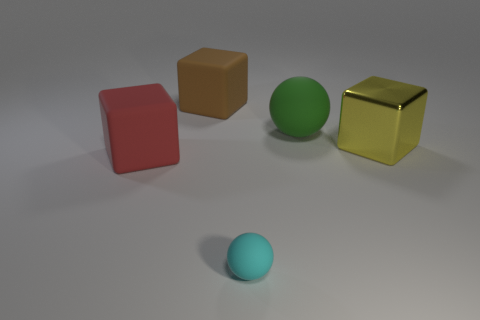Is there any other thing that has the same size as the cyan rubber sphere?
Your response must be concise. No. The cube that is to the left of the rubber block that is on the right side of the matte object on the left side of the brown thing is made of what material?
Your response must be concise. Rubber. There is a rubber sphere behind the cyan rubber sphere; is it the same size as the small cyan sphere?
Offer a terse response. No. How many tiny things are either red metal spheres or cyan objects?
Make the answer very short. 1. What shape is the brown rubber object that is the same size as the shiny block?
Your answer should be very brief. Cube. How many objects are balls right of the small cyan object or large blue blocks?
Offer a very short reply. 1. Are there more balls that are to the right of the small cyan thing than large brown blocks that are to the left of the large yellow thing?
Your answer should be compact. No. Is the material of the large yellow thing the same as the cyan thing?
Offer a terse response. No. There is a large object that is in front of the big green rubber sphere and on the right side of the brown matte thing; what is its shape?
Keep it short and to the point. Cube. The tiny object that is made of the same material as the big green ball is what shape?
Provide a succinct answer. Sphere. 